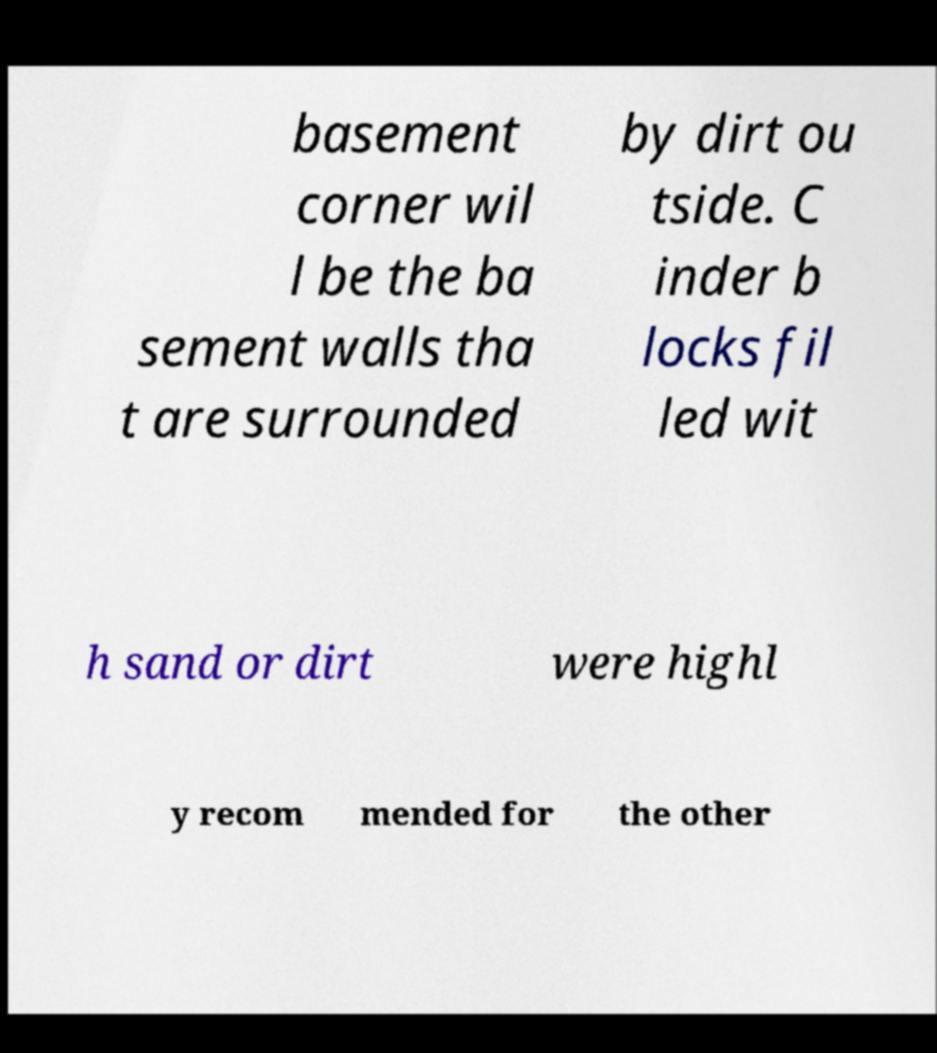For documentation purposes, I need the text within this image transcribed. Could you provide that? basement corner wil l be the ba sement walls tha t are surrounded by dirt ou tside. C inder b locks fil led wit h sand or dirt were highl y recom mended for the other 